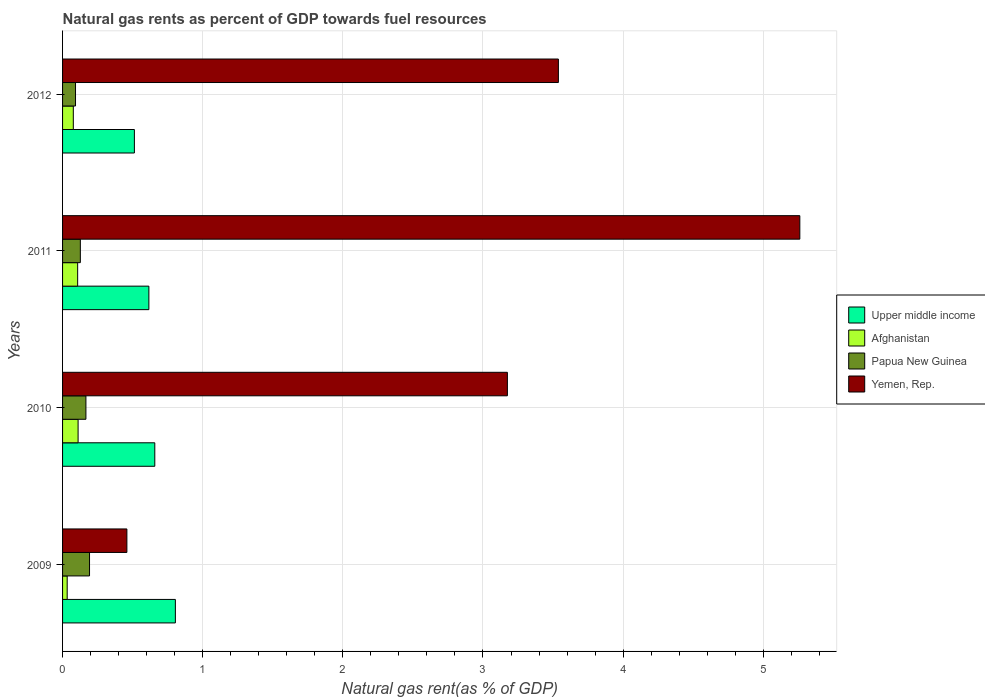Are the number of bars per tick equal to the number of legend labels?
Make the answer very short. Yes. Are the number of bars on each tick of the Y-axis equal?
Provide a short and direct response. Yes. What is the label of the 2nd group of bars from the top?
Give a very brief answer. 2011. What is the natural gas rent in Papua New Guinea in 2009?
Offer a terse response. 0.19. Across all years, what is the maximum natural gas rent in Upper middle income?
Ensure brevity in your answer.  0.8. Across all years, what is the minimum natural gas rent in Upper middle income?
Make the answer very short. 0.51. In which year was the natural gas rent in Papua New Guinea minimum?
Provide a succinct answer. 2012. What is the total natural gas rent in Upper middle income in the graph?
Your answer should be very brief. 2.59. What is the difference between the natural gas rent in Yemen, Rep. in 2010 and that in 2011?
Give a very brief answer. -2.09. What is the difference between the natural gas rent in Upper middle income in 2010 and the natural gas rent in Papua New Guinea in 2012?
Your answer should be compact. 0.57. What is the average natural gas rent in Afghanistan per year?
Give a very brief answer. 0.08. In the year 2012, what is the difference between the natural gas rent in Afghanistan and natural gas rent in Yemen, Rep.?
Your answer should be compact. -3.46. What is the ratio of the natural gas rent in Afghanistan in 2009 to that in 2012?
Offer a terse response. 0.43. What is the difference between the highest and the second highest natural gas rent in Afghanistan?
Provide a short and direct response. 0. What is the difference between the highest and the lowest natural gas rent in Yemen, Rep.?
Provide a short and direct response. 4.8. In how many years, is the natural gas rent in Upper middle income greater than the average natural gas rent in Upper middle income taken over all years?
Offer a very short reply. 2. Is it the case that in every year, the sum of the natural gas rent in Papua New Guinea and natural gas rent in Upper middle income is greater than the sum of natural gas rent in Yemen, Rep. and natural gas rent in Afghanistan?
Provide a succinct answer. No. What does the 3rd bar from the top in 2009 represents?
Your answer should be very brief. Afghanistan. What does the 2nd bar from the bottom in 2009 represents?
Offer a terse response. Afghanistan. Is it the case that in every year, the sum of the natural gas rent in Afghanistan and natural gas rent in Yemen, Rep. is greater than the natural gas rent in Upper middle income?
Provide a succinct answer. No. How many bars are there?
Offer a terse response. 16. How many years are there in the graph?
Your answer should be very brief. 4. What is the difference between two consecutive major ticks on the X-axis?
Keep it short and to the point. 1. Are the values on the major ticks of X-axis written in scientific E-notation?
Make the answer very short. No. Does the graph contain any zero values?
Your answer should be compact. No. Where does the legend appear in the graph?
Give a very brief answer. Center right. How many legend labels are there?
Offer a very short reply. 4. What is the title of the graph?
Provide a short and direct response. Natural gas rents as percent of GDP towards fuel resources. What is the label or title of the X-axis?
Your answer should be very brief. Natural gas rent(as % of GDP). What is the label or title of the Y-axis?
Your answer should be compact. Years. What is the Natural gas rent(as % of GDP) in Upper middle income in 2009?
Your response must be concise. 0.8. What is the Natural gas rent(as % of GDP) in Afghanistan in 2009?
Offer a very short reply. 0.03. What is the Natural gas rent(as % of GDP) in Papua New Guinea in 2009?
Offer a very short reply. 0.19. What is the Natural gas rent(as % of GDP) in Yemen, Rep. in 2009?
Ensure brevity in your answer.  0.46. What is the Natural gas rent(as % of GDP) of Upper middle income in 2010?
Ensure brevity in your answer.  0.66. What is the Natural gas rent(as % of GDP) of Afghanistan in 2010?
Make the answer very short. 0.11. What is the Natural gas rent(as % of GDP) in Papua New Guinea in 2010?
Your answer should be very brief. 0.17. What is the Natural gas rent(as % of GDP) of Yemen, Rep. in 2010?
Provide a short and direct response. 3.17. What is the Natural gas rent(as % of GDP) of Upper middle income in 2011?
Your answer should be compact. 0.62. What is the Natural gas rent(as % of GDP) of Afghanistan in 2011?
Give a very brief answer. 0.11. What is the Natural gas rent(as % of GDP) of Papua New Guinea in 2011?
Provide a short and direct response. 0.13. What is the Natural gas rent(as % of GDP) in Yemen, Rep. in 2011?
Offer a terse response. 5.26. What is the Natural gas rent(as % of GDP) in Upper middle income in 2012?
Make the answer very short. 0.51. What is the Natural gas rent(as % of GDP) of Afghanistan in 2012?
Give a very brief answer. 0.08. What is the Natural gas rent(as % of GDP) of Papua New Guinea in 2012?
Make the answer very short. 0.09. What is the Natural gas rent(as % of GDP) of Yemen, Rep. in 2012?
Offer a very short reply. 3.54. Across all years, what is the maximum Natural gas rent(as % of GDP) of Upper middle income?
Provide a short and direct response. 0.8. Across all years, what is the maximum Natural gas rent(as % of GDP) in Afghanistan?
Your answer should be compact. 0.11. Across all years, what is the maximum Natural gas rent(as % of GDP) of Papua New Guinea?
Offer a very short reply. 0.19. Across all years, what is the maximum Natural gas rent(as % of GDP) of Yemen, Rep.?
Offer a very short reply. 5.26. Across all years, what is the minimum Natural gas rent(as % of GDP) of Upper middle income?
Offer a terse response. 0.51. Across all years, what is the minimum Natural gas rent(as % of GDP) of Afghanistan?
Make the answer very short. 0.03. Across all years, what is the minimum Natural gas rent(as % of GDP) in Papua New Guinea?
Make the answer very short. 0.09. Across all years, what is the minimum Natural gas rent(as % of GDP) of Yemen, Rep.?
Provide a succinct answer. 0.46. What is the total Natural gas rent(as % of GDP) of Upper middle income in the graph?
Offer a terse response. 2.59. What is the total Natural gas rent(as % of GDP) in Afghanistan in the graph?
Your answer should be compact. 0.33. What is the total Natural gas rent(as % of GDP) in Papua New Guinea in the graph?
Give a very brief answer. 0.58. What is the total Natural gas rent(as % of GDP) of Yemen, Rep. in the graph?
Offer a terse response. 12.43. What is the difference between the Natural gas rent(as % of GDP) in Upper middle income in 2009 and that in 2010?
Offer a very short reply. 0.15. What is the difference between the Natural gas rent(as % of GDP) of Afghanistan in 2009 and that in 2010?
Make the answer very short. -0.08. What is the difference between the Natural gas rent(as % of GDP) in Papua New Guinea in 2009 and that in 2010?
Your response must be concise. 0.03. What is the difference between the Natural gas rent(as % of GDP) of Yemen, Rep. in 2009 and that in 2010?
Give a very brief answer. -2.72. What is the difference between the Natural gas rent(as % of GDP) of Upper middle income in 2009 and that in 2011?
Your answer should be very brief. 0.19. What is the difference between the Natural gas rent(as % of GDP) in Afghanistan in 2009 and that in 2011?
Provide a succinct answer. -0.07. What is the difference between the Natural gas rent(as % of GDP) of Papua New Guinea in 2009 and that in 2011?
Give a very brief answer. 0.07. What is the difference between the Natural gas rent(as % of GDP) in Yemen, Rep. in 2009 and that in 2011?
Your answer should be very brief. -4.8. What is the difference between the Natural gas rent(as % of GDP) in Upper middle income in 2009 and that in 2012?
Offer a very short reply. 0.29. What is the difference between the Natural gas rent(as % of GDP) of Afghanistan in 2009 and that in 2012?
Provide a succinct answer. -0.04. What is the difference between the Natural gas rent(as % of GDP) of Papua New Guinea in 2009 and that in 2012?
Provide a short and direct response. 0.1. What is the difference between the Natural gas rent(as % of GDP) of Yemen, Rep. in 2009 and that in 2012?
Your answer should be very brief. -3.08. What is the difference between the Natural gas rent(as % of GDP) of Upper middle income in 2010 and that in 2011?
Provide a succinct answer. 0.04. What is the difference between the Natural gas rent(as % of GDP) in Afghanistan in 2010 and that in 2011?
Give a very brief answer. 0. What is the difference between the Natural gas rent(as % of GDP) of Papua New Guinea in 2010 and that in 2011?
Your answer should be very brief. 0.04. What is the difference between the Natural gas rent(as % of GDP) in Yemen, Rep. in 2010 and that in 2011?
Provide a succinct answer. -2.09. What is the difference between the Natural gas rent(as % of GDP) of Upper middle income in 2010 and that in 2012?
Make the answer very short. 0.15. What is the difference between the Natural gas rent(as % of GDP) in Afghanistan in 2010 and that in 2012?
Keep it short and to the point. 0.03. What is the difference between the Natural gas rent(as % of GDP) in Papua New Guinea in 2010 and that in 2012?
Your response must be concise. 0.07. What is the difference between the Natural gas rent(as % of GDP) of Yemen, Rep. in 2010 and that in 2012?
Ensure brevity in your answer.  -0.36. What is the difference between the Natural gas rent(as % of GDP) of Upper middle income in 2011 and that in 2012?
Provide a succinct answer. 0.1. What is the difference between the Natural gas rent(as % of GDP) of Afghanistan in 2011 and that in 2012?
Make the answer very short. 0.03. What is the difference between the Natural gas rent(as % of GDP) of Papua New Guinea in 2011 and that in 2012?
Offer a very short reply. 0.03. What is the difference between the Natural gas rent(as % of GDP) in Yemen, Rep. in 2011 and that in 2012?
Give a very brief answer. 1.72. What is the difference between the Natural gas rent(as % of GDP) of Upper middle income in 2009 and the Natural gas rent(as % of GDP) of Afghanistan in 2010?
Provide a short and direct response. 0.69. What is the difference between the Natural gas rent(as % of GDP) of Upper middle income in 2009 and the Natural gas rent(as % of GDP) of Papua New Guinea in 2010?
Keep it short and to the point. 0.64. What is the difference between the Natural gas rent(as % of GDP) in Upper middle income in 2009 and the Natural gas rent(as % of GDP) in Yemen, Rep. in 2010?
Your response must be concise. -2.37. What is the difference between the Natural gas rent(as % of GDP) of Afghanistan in 2009 and the Natural gas rent(as % of GDP) of Papua New Guinea in 2010?
Keep it short and to the point. -0.13. What is the difference between the Natural gas rent(as % of GDP) of Afghanistan in 2009 and the Natural gas rent(as % of GDP) of Yemen, Rep. in 2010?
Ensure brevity in your answer.  -3.14. What is the difference between the Natural gas rent(as % of GDP) in Papua New Guinea in 2009 and the Natural gas rent(as % of GDP) in Yemen, Rep. in 2010?
Offer a terse response. -2.98. What is the difference between the Natural gas rent(as % of GDP) of Upper middle income in 2009 and the Natural gas rent(as % of GDP) of Afghanistan in 2011?
Provide a short and direct response. 0.7. What is the difference between the Natural gas rent(as % of GDP) of Upper middle income in 2009 and the Natural gas rent(as % of GDP) of Papua New Guinea in 2011?
Give a very brief answer. 0.68. What is the difference between the Natural gas rent(as % of GDP) in Upper middle income in 2009 and the Natural gas rent(as % of GDP) in Yemen, Rep. in 2011?
Give a very brief answer. -4.46. What is the difference between the Natural gas rent(as % of GDP) in Afghanistan in 2009 and the Natural gas rent(as % of GDP) in Papua New Guinea in 2011?
Your response must be concise. -0.09. What is the difference between the Natural gas rent(as % of GDP) of Afghanistan in 2009 and the Natural gas rent(as % of GDP) of Yemen, Rep. in 2011?
Your answer should be compact. -5.23. What is the difference between the Natural gas rent(as % of GDP) in Papua New Guinea in 2009 and the Natural gas rent(as % of GDP) in Yemen, Rep. in 2011?
Your answer should be very brief. -5.07. What is the difference between the Natural gas rent(as % of GDP) of Upper middle income in 2009 and the Natural gas rent(as % of GDP) of Afghanistan in 2012?
Make the answer very short. 0.73. What is the difference between the Natural gas rent(as % of GDP) in Upper middle income in 2009 and the Natural gas rent(as % of GDP) in Papua New Guinea in 2012?
Offer a very short reply. 0.71. What is the difference between the Natural gas rent(as % of GDP) in Upper middle income in 2009 and the Natural gas rent(as % of GDP) in Yemen, Rep. in 2012?
Give a very brief answer. -2.73. What is the difference between the Natural gas rent(as % of GDP) of Afghanistan in 2009 and the Natural gas rent(as % of GDP) of Papua New Guinea in 2012?
Ensure brevity in your answer.  -0.06. What is the difference between the Natural gas rent(as % of GDP) in Afghanistan in 2009 and the Natural gas rent(as % of GDP) in Yemen, Rep. in 2012?
Your response must be concise. -3.5. What is the difference between the Natural gas rent(as % of GDP) of Papua New Guinea in 2009 and the Natural gas rent(as % of GDP) of Yemen, Rep. in 2012?
Offer a terse response. -3.35. What is the difference between the Natural gas rent(as % of GDP) of Upper middle income in 2010 and the Natural gas rent(as % of GDP) of Afghanistan in 2011?
Offer a very short reply. 0.55. What is the difference between the Natural gas rent(as % of GDP) in Upper middle income in 2010 and the Natural gas rent(as % of GDP) in Papua New Guinea in 2011?
Your response must be concise. 0.53. What is the difference between the Natural gas rent(as % of GDP) in Upper middle income in 2010 and the Natural gas rent(as % of GDP) in Yemen, Rep. in 2011?
Keep it short and to the point. -4.6. What is the difference between the Natural gas rent(as % of GDP) in Afghanistan in 2010 and the Natural gas rent(as % of GDP) in Papua New Guinea in 2011?
Ensure brevity in your answer.  -0.02. What is the difference between the Natural gas rent(as % of GDP) of Afghanistan in 2010 and the Natural gas rent(as % of GDP) of Yemen, Rep. in 2011?
Provide a succinct answer. -5.15. What is the difference between the Natural gas rent(as % of GDP) of Papua New Guinea in 2010 and the Natural gas rent(as % of GDP) of Yemen, Rep. in 2011?
Keep it short and to the point. -5.09. What is the difference between the Natural gas rent(as % of GDP) of Upper middle income in 2010 and the Natural gas rent(as % of GDP) of Afghanistan in 2012?
Your response must be concise. 0.58. What is the difference between the Natural gas rent(as % of GDP) in Upper middle income in 2010 and the Natural gas rent(as % of GDP) in Papua New Guinea in 2012?
Provide a short and direct response. 0.57. What is the difference between the Natural gas rent(as % of GDP) of Upper middle income in 2010 and the Natural gas rent(as % of GDP) of Yemen, Rep. in 2012?
Provide a short and direct response. -2.88. What is the difference between the Natural gas rent(as % of GDP) in Afghanistan in 2010 and the Natural gas rent(as % of GDP) in Papua New Guinea in 2012?
Offer a very short reply. 0.02. What is the difference between the Natural gas rent(as % of GDP) in Afghanistan in 2010 and the Natural gas rent(as % of GDP) in Yemen, Rep. in 2012?
Keep it short and to the point. -3.43. What is the difference between the Natural gas rent(as % of GDP) of Papua New Guinea in 2010 and the Natural gas rent(as % of GDP) of Yemen, Rep. in 2012?
Your answer should be compact. -3.37. What is the difference between the Natural gas rent(as % of GDP) of Upper middle income in 2011 and the Natural gas rent(as % of GDP) of Afghanistan in 2012?
Your answer should be very brief. 0.54. What is the difference between the Natural gas rent(as % of GDP) in Upper middle income in 2011 and the Natural gas rent(as % of GDP) in Papua New Guinea in 2012?
Give a very brief answer. 0.52. What is the difference between the Natural gas rent(as % of GDP) of Upper middle income in 2011 and the Natural gas rent(as % of GDP) of Yemen, Rep. in 2012?
Keep it short and to the point. -2.92. What is the difference between the Natural gas rent(as % of GDP) of Afghanistan in 2011 and the Natural gas rent(as % of GDP) of Papua New Guinea in 2012?
Your answer should be compact. 0.02. What is the difference between the Natural gas rent(as % of GDP) in Afghanistan in 2011 and the Natural gas rent(as % of GDP) in Yemen, Rep. in 2012?
Offer a terse response. -3.43. What is the difference between the Natural gas rent(as % of GDP) in Papua New Guinea in 2011 and the Natural gas rent(as % of GDP) in Yemen, Rep. in 2012?
Provide a succinct answer. -3.41. What is the average Natural gas rent(as % of GDP) of Upper middle income per year?
Your response must be concise. 0.65. What is the average Natural gas rent(as % of GDP) of Afghanistan per year?
Offer a very short reply. 0.08. What is the average Natural gas rent(as % of GDP) in Papua New Guinea per year?
Offer a terse response. 0.14. What is the average Natural gas rent(as % of GDP) in Yemen, Rep. per year?
Give a very brief answer. 3.11. In the year 2009, what is the difference between the Natural gas rent(as % of GDP) in Upper middle income and Natural gas rent(as % of GDP) in Afghanistan?
Your response must be concise. 0.77. In the year 2009, what is the difference between the Natural gas rent(as % of GDP) of Upper middle income and Natural gas rent(as % of GDP) of Papua New Guinea?
Ensure brevity in your answer.  0.61. In the year 2009, what is the difference between the Natural gas rent(as % of GDP) in Upper middle income and Natural gas rent(as % of GDP) in Yemen, Rep.?
Give a very brief answer. 0.35. In the year 2009, what is the difference between the Natural gas rent(as % of GDP) in Afghanistan and Natural gas rent(as % of GDP) in Papua New Guinea?
Give a very brief answer. -0.16. In the year 2009, what is the difference between the Natural gas rent(as % of GDP) of Afghanistan and Natural gas rent(as % of GDP) of Yemen, Rep.?
Make the answer very short. -0.43. In the year 2009, what is the difference between the Natural gas rent(as % of GDP) of Papua New Guinea and Natural gas rent(as % of GDP) of Yemen, Rep.?
Your answer should be very brief. -0.27. In the year 2010, what is the difference between the Natural gas rent(as % of GDP) in Upper middle income and Natural gas rent(as % of GDP) in Afghanistan?
Your response must be concise. 0.55. In the year 2010, what is the difference between the Natural gas rent(as % of GDP) in Upper middle income and Natural gas rent(as % of GDP) in Papua New Guinea?
Keep it short and to the point. 0.49. In the year 2010, what is the difference between the Natural gas rent(as % of GDP) in Upper middle income and Natural gas rent(as % of GDP) in Yemen, Rep.?
Your answer should be very brief. -2.52. In the year 2010, what is the difference between the Natural gas rent(as % of GDP) of Afghanistan and Natural gas rent(as % of GDP) of Papua New Guinea?
Offer a very short reply. -0.06. In the year 2010, what is the difference between the Natural gas rent(as % of GDP) of Afghanistan and Natural gas rent(as % of GDP) of Yemen, Rep.?
Offer a terse response. -3.06. In the year 2010, what is the difference between the Natural gas rent(as % of GDP) of Papua New Guinea and Natural gas rent(as % of GDP) of Yemen, Rep.?
Offer a terse response. -3.01. In the year 2011, what is the difference between the Natural gas rent(as % of GDP) in Upper middle income and Natural gas rent(as % of GDP) in Afghanistan?
Keep it short and to the point. 0.51. In the year 2011, what is the difference between the Natural gas rent(as % of GDP) of Upper middle income and Natural gas rent(as % of GDP) of Papua New Guinea?
Give a very brief answer. 0.49. In the year 2011, what is the difference between the Natural gas rent(as % of GDP) in Upper middle income and Natural gas rent(as % of GDP) in Yemen, Rep.?
Ensure brevity in your answer.  -4.64. In the year 2011, what is the difference between the Natural gas rent(as % of GDP) of Afghanistan and Natural gas rent(as % of GDP) of Papua New Guinea?
Keep it short and to the point. -0.02. In the year 2011, what is the difference between the Natural gas rent(as % of GDP) of Afghanistan and Natural gas rent(as % of GDP) of Yemen, Rep.?
Give a very brief answer. -5.15. In the year 2011, what is the difference between the Natural gas rent(as % of GDP) of Papua New Guinea and Natural gas rent(as % of GDP) of Yemen, Rep.?
Offer a very short reply. -5.13. In the year 2012, what is the difference between the Natural gas rent(as % of GDP) in Upper middle income and Natural gas rent(as % of GDP) in Afghanistan?
Offer a very short reply. 0.44. In the year 2012, what is the difference between the Natural gas rent(as % of GDP) in Upper middle income and Natural gas rent(as % of GDP) in Papua New Guinea?
Keep it short and to the point. 0.42. In the year 2012, what is the difference between the Natural gas rent(as % of GDP) in Upper middle income and Natural gas rent(as % of GDP) in Yemen, Rep.?
Keep it short and to the point. -3.03. In the year 2012, what is the difference between the Natural gas rent(as % of GDP) of Afghanistan and Natural gas rent(as % of GDP) of Papua New Guinea?
Ensure brevity in your answer.  -0.02. In the year 2012, what is the difference between the Natural gas rent(as % of GDP) in Afghanistan and Natural gas rent(as % of GDP) in Yemen, Rep.?
Your answer should be very brief. -3.46. In the year 2012, what is the difference between the Natural gas rent(as % of GDP) of Papua New Guinea and Natural gas rent(as % of GDP) of Yemen, Rep.?
Your answer should be very brief. -3.45. What is the ratio of the Natural gas rent(as % of GDP) of Upper middle income in 2009 to that in 2010?
Ensure brevity in your answer.  1.22. What is the ratio of the Natural gas rent(as % of GDP) of Afghanistan in 2009 to that in 2010?
Give a very brief answer. 0.3. What is the ratio of the Natural gas rent(as % of GDP) in Papua New Guinea in 2009 to that in 2010?
Give a very brief answer. 1.15. What is the ratio of the Natural gas rent(as % of GDP) in Yemen, Rep. in 2009 to that in 2010?
Ensure brevity in your answer.  0.14. What is the ratio of the Natural gas rent(as % of GDP) in Upper middle income in 2009 to that in 2011?
Offer a terse response. 1.31. What is the ratio of the Natural gas rent(as % of GDP) of Afghanistan in 2009 to that in 2011?
Make the answer very short. 0.31. What is the ratio of the Natural gas rent(as % of GDP) of Papua New Guinea in 2009 to that in 2011?
Make the answer very short. 1.52. What is the ratio of the Natural gas rent(as % of GDP) in Yemen, Rep. in 2009 to that in 2011?
Your answer should be very brief. 0.09. What is the ratio of the Natural gas rent(as % of GDP) in Upper middle income in 2009 to that in 2012?
Make the answer very short. 1.57. What is the ratio of the Natural gas rent(as % of GDP) of Afghanistan in 2009 to that in 2012?
Your answer should be very brief. 0.43. What is the ratio of the Natural gas rent(as % of GDP) of Papua New Guinea in 2009 to that in 2012?
Ensure brevity in your answer.  2.08. What is the ratio of the Natural gas rent(as % of GDP) of Yemen, Rep. in 2009 to that in 2012?
Provide a succinct answer. 0.13. What is the ratio of the Natural gas rent(as % of GDP) of Upper middle income in 2010 to that in 2011?
Keep it short and to the point. 1.07. What is the ratio of the Natural gas rent(as % of GDP) of Afghanistan in 2010 to that in 2011?
Offer a terse response. 1.03. What is the ratio of the Natural gas rent(as % of GDP) in Papua New Guinea in 2010 to that in 2011?
Give a very brief answer. 1.31. What is the ratio of the Natural gas rent(as % of GDP) in Yemen, Rep. in 2010 to that in 2011?
Ensure brevity in your answer.  0.6. What is the ratio of the Natural gas rent(as % of GDP) of Upper middle income in 2010 to that in 2012?
Ensure brevity in your answer.  1.28. What is the ratio of the Natural gas rent(as % of GDP) of Afghanistan in 2010 to that in 2012?
Offer a very short reply. 1.44. What is the ratio of the Natural gas rent(as % of GDP) of Papua New Guinea in 2010 to that in 2012?
Offer a terse response. 1.8. What is the ratio of the Natural gas rent(as % of GDP) in Yemen, Rep. in 2010 to that in 2012?
Your answer should be compact. 0.9. What is the ratio of the Natural gas rent(as % of GDP) in Upper middle income in 2011 to that in 2012?
Your response must be concise. 1.2. What is the ratio of the Natural gas rent(as % of GDP) in Afghanistan in 2011 to that in 2012?
Give a very brief answer. 1.4. What is the ratio of the Natural gas rent(as % of GDP) of Papua New Guinea in 2011 to that in 2012?
Your answer should be very brief. 1.37. What is the ratio of the Natural gas rent(as % of GDP) in Yemen, Rep. in 2011 to that in 2012?
Ensure brevity in your answer.  1.49. What is the difference between the highest and the second highest Natural gas rent(as % of GDP) of Upper middle income?
Your answer should be very brief. 0.15. What is the difference between the highest and the second highest Natural gas rent(as % of GDP) in Afghanistan?
Ensure brevity in your answer.  0. What is the difference between the highest and the second highest Natural gas rent(as % of GDP) of Papua New Guinea?
Provide a short and direct response. 0.03. What is the difference between the highest and the second highest Natural gas rent(as % of GDP) in Yemen, Rep.?
Make the answer very short. 1.72. What is the difference between the highest and the lowest Natural gas rent(as % of GDP) in Upper middle income?
Offer a very short reply. 0.29. What is the difference between the highest and the lowest Natural gas rent(as % of GDP) in Afghanistan?
Offer a terse response. 0.08. What is the difference between the highest and the lowest Natural gas rent(as % of GDP) in Yemen, Rep.?
Your answer should be very brief. 4.8. 